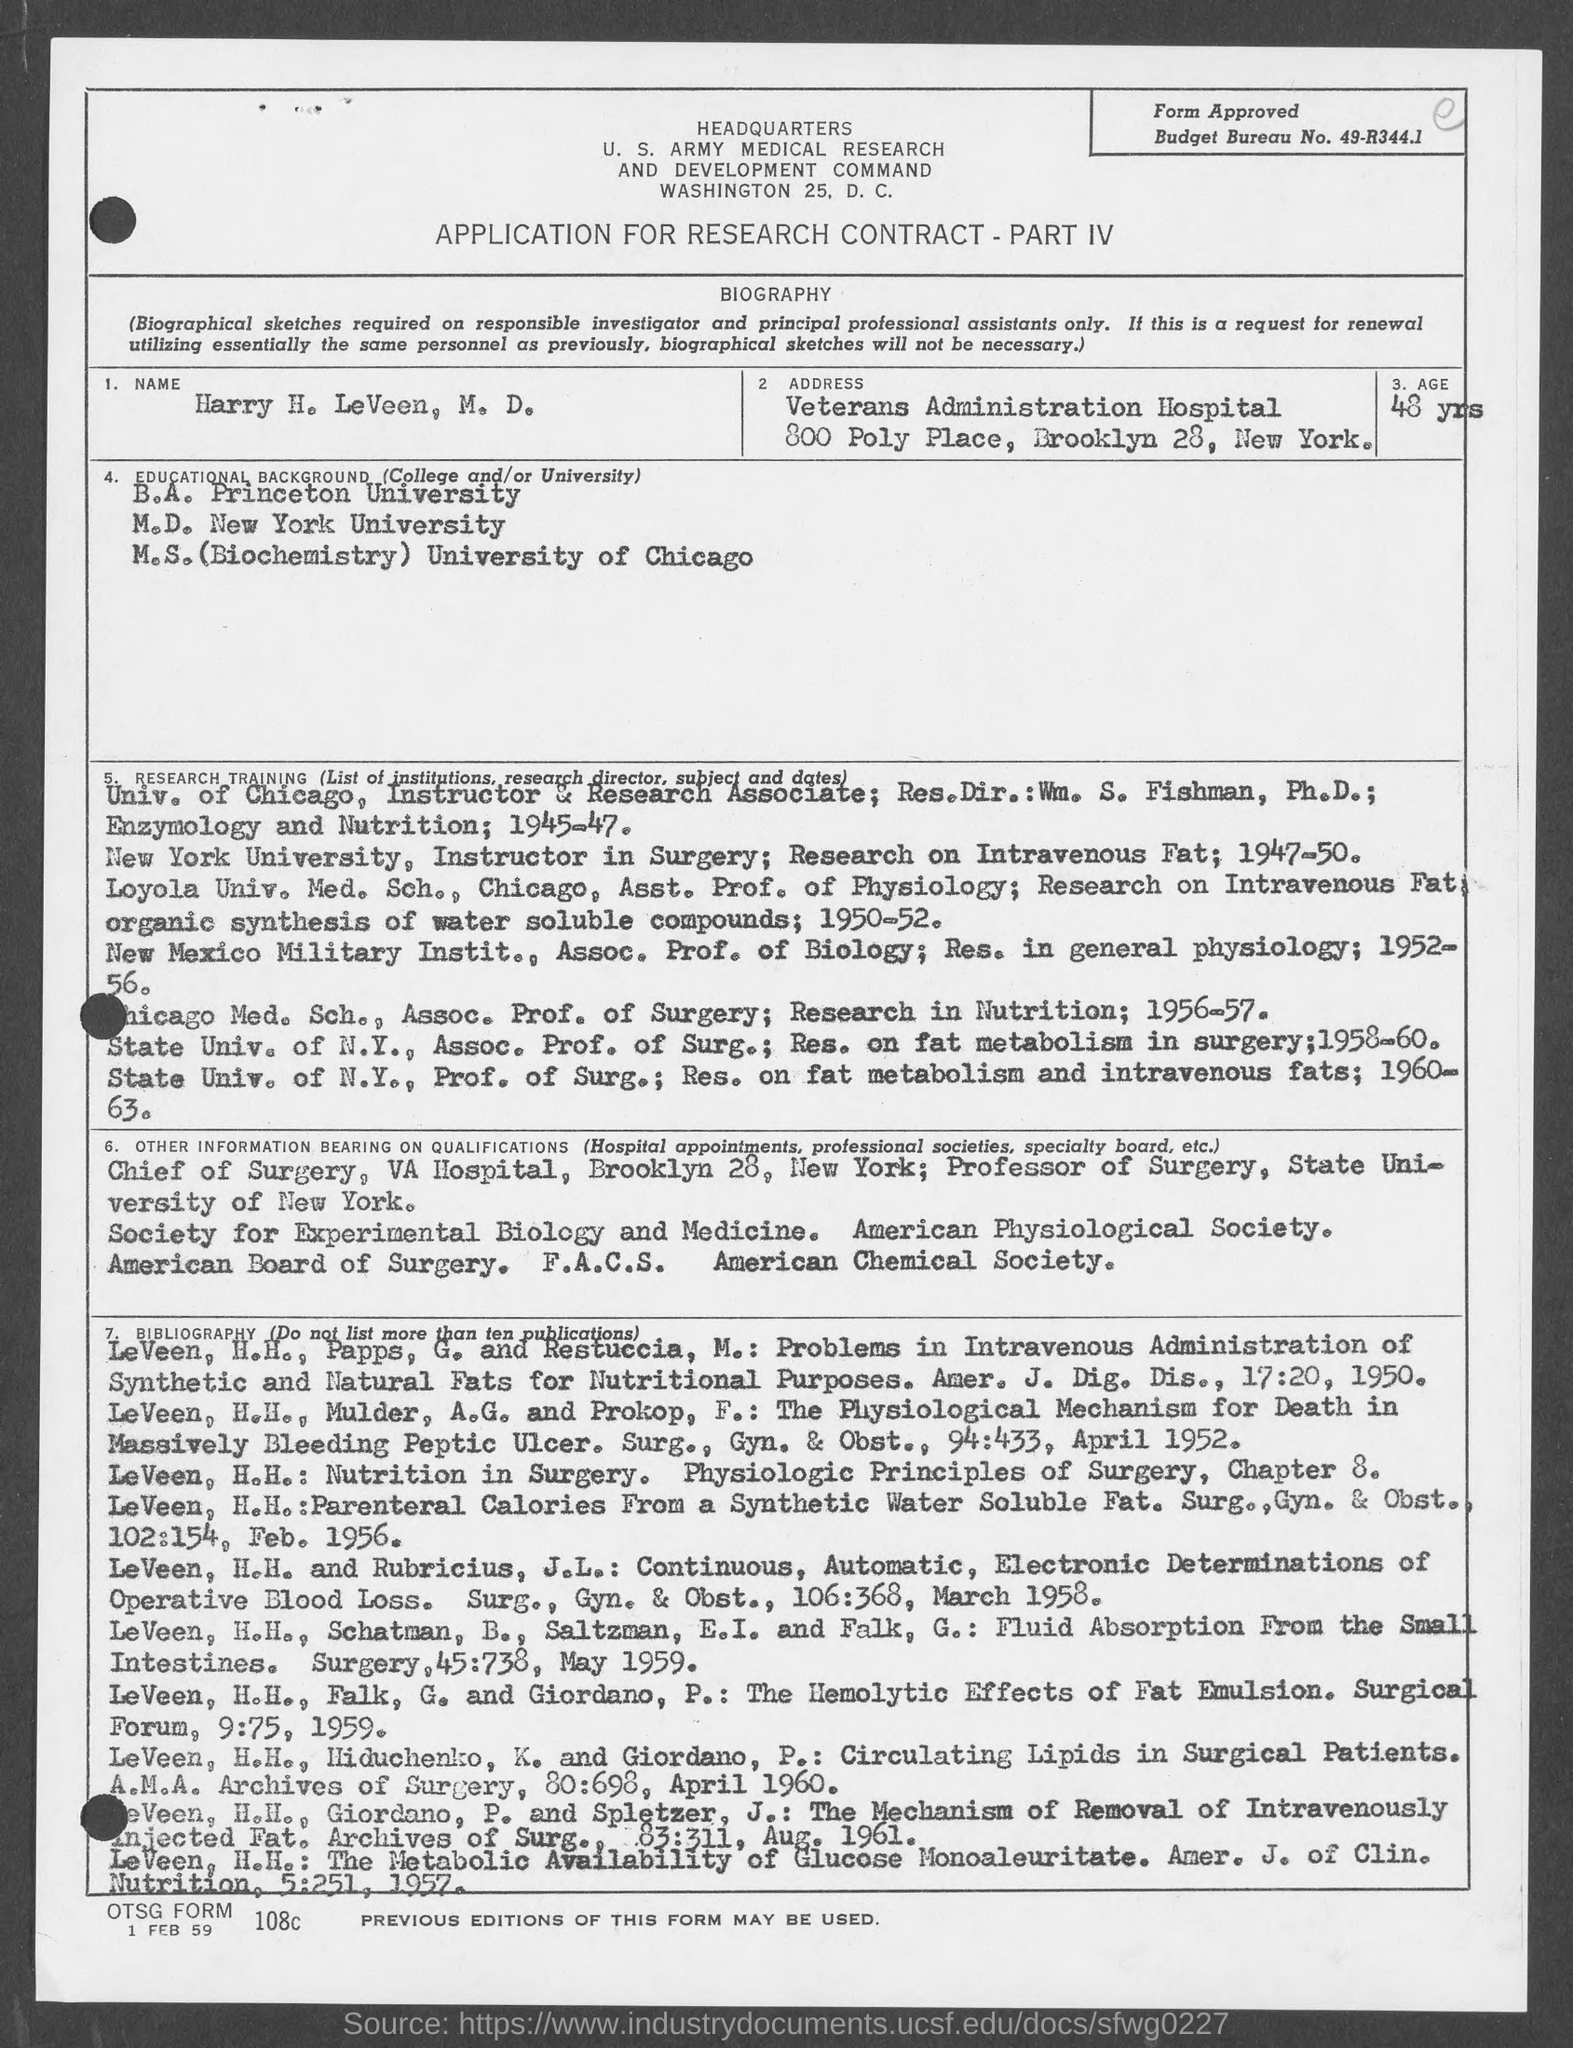What is the age mentioned in the given form ?
Provide a short and direct response. 48 yrs. What is the budget bureau no. mentioned in the given form ?
Give a very brief answer. 49-R344.1. From which university b.a. was completed ?
Your response must be concise. Princeton University. From which university m.d. was completed ?
Your answer should be very brief. New York University. From which university m.s.(biochemistry) was completed ?
Your answer should be very brief. University of chicago. 